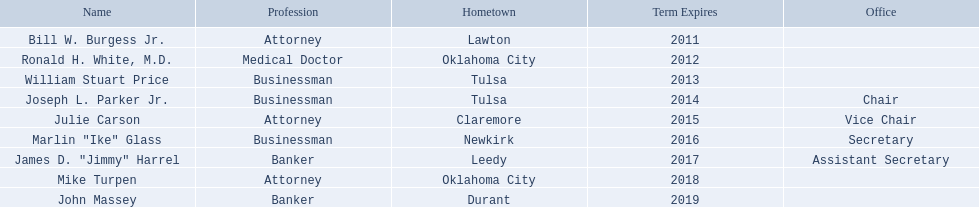What are the full names of oklahoma state regents for higher academics? Bill W. Burgess Jr., Ronald H. White, M.D., William Stuart Price, Joseph L. Parker Jr., Julie Carson, Marlin "Ike" Glass, James D. "Jimmy" Harrel, Mike Turpen, John Massey. Which ones are businesspeople? William Stuart Price, Joseph L. Parker Jr., Marlin "Ike" Glass. Out of them, who originates from tulsa? William Stuart Price, Joseph L. Parker Jr. Whose term ends in 2014? Joseph L. Parker Jr. 